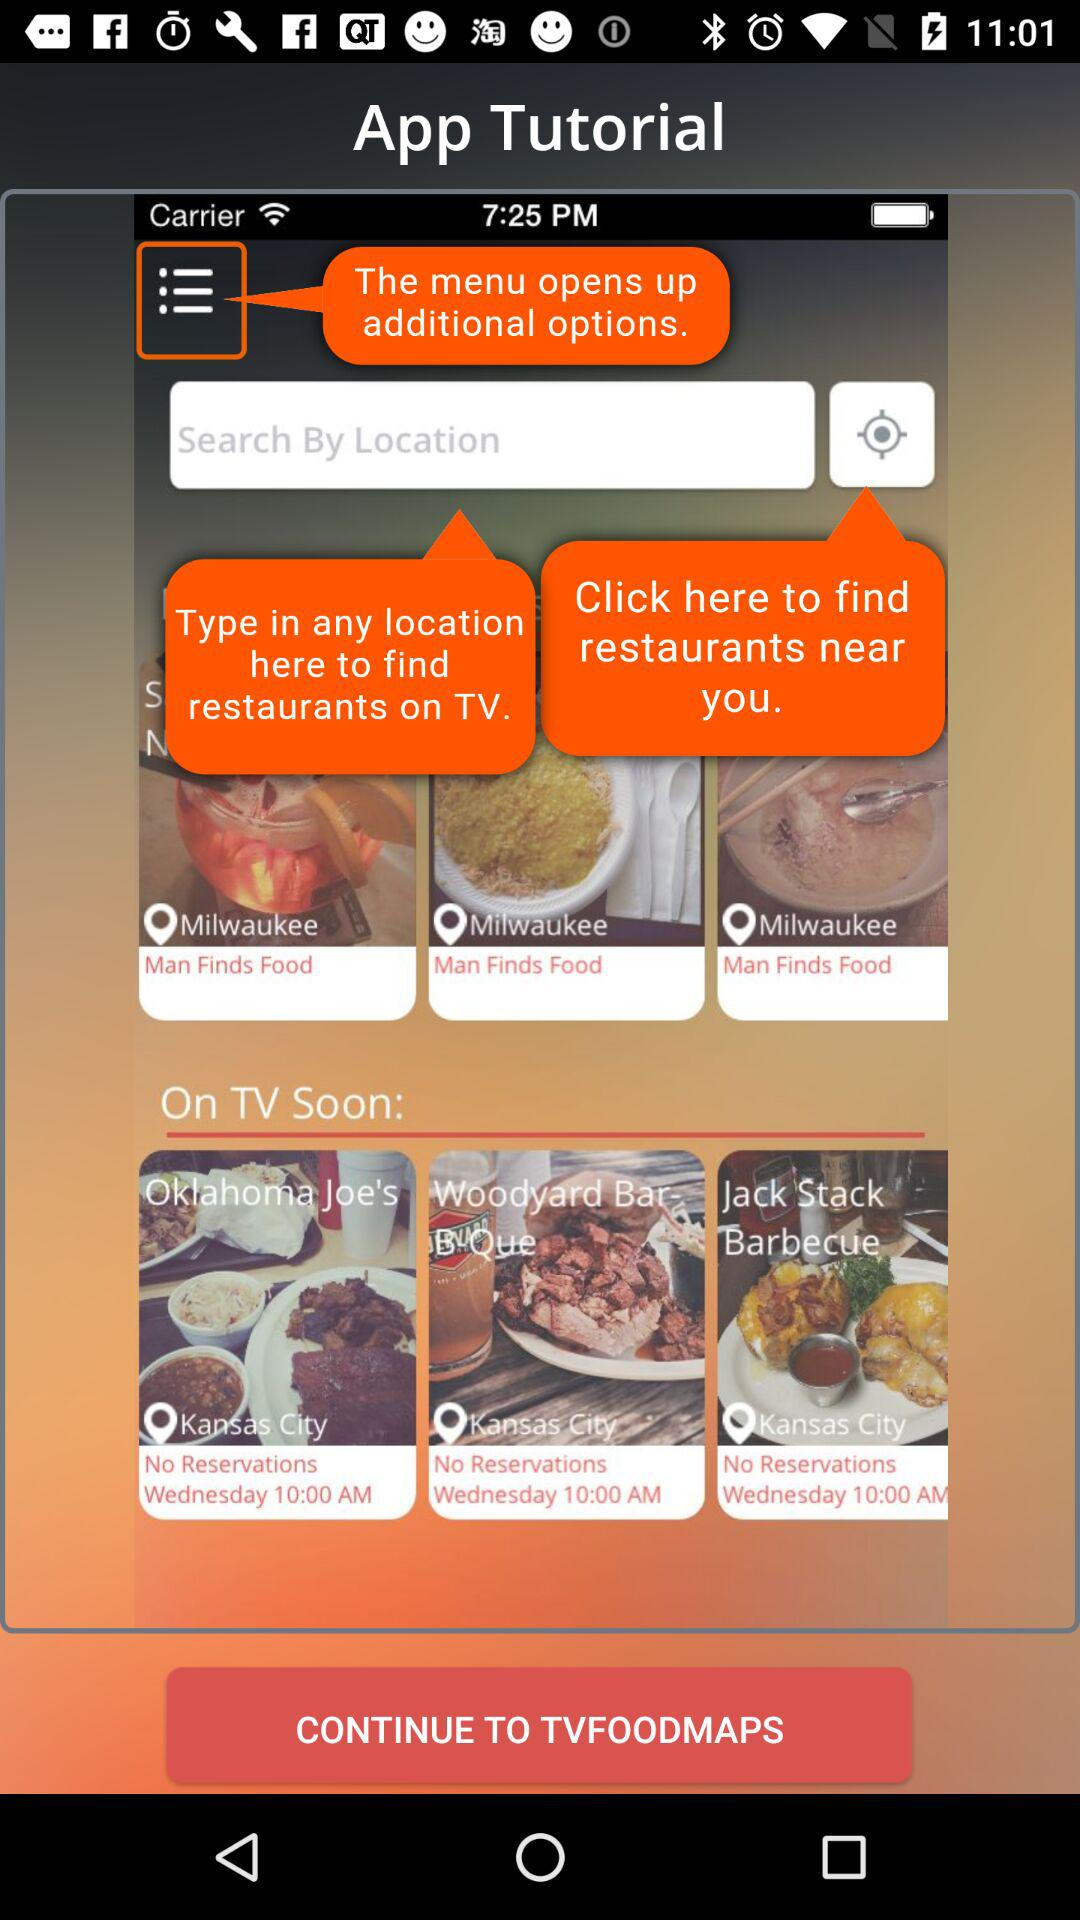Where is "Okhlahoma Joe's" restaurant located? It is located in Kansas City. 